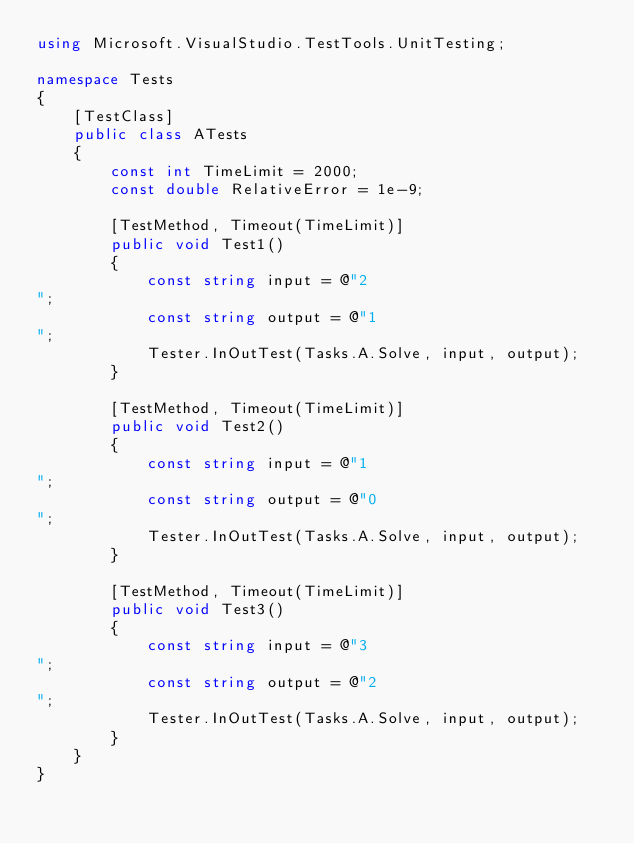<code> <loc_0><loc_0><loc_500><loc_500><_C#_>using Microsoft.VisualStudio.TestTools.UnitTesting;

namespace Tests
{
    [TestClass]
    public class ATests
    {
        const int TimeLimit = 2000;
        const double RelativeError = 1e-9;

        [TestMethod, Timeout(TimeLimit)]
        public void Test1()
        {
            const string input = @"2
";
            const string output = @"1
";
            Tester.InOutTest(Tasks.A.Solve, input, output);
        }

        [TestMethod, Timeout(TimeLimit)]
        public void Test2()
        {
            const string input = @"1
";
            const string output = @"0
";
            Tester.InOutTest(Tasks.A.Solve, input, output);
        }

        [TestMethod, Timeout(TimeLimit)]
        public void Test3()
        {
            const string input = @"3
";
            const string output = @"2
";
            Tester.InOutTest(Tasks.A.Solve, input, output);
        }
    }
}
</code> 